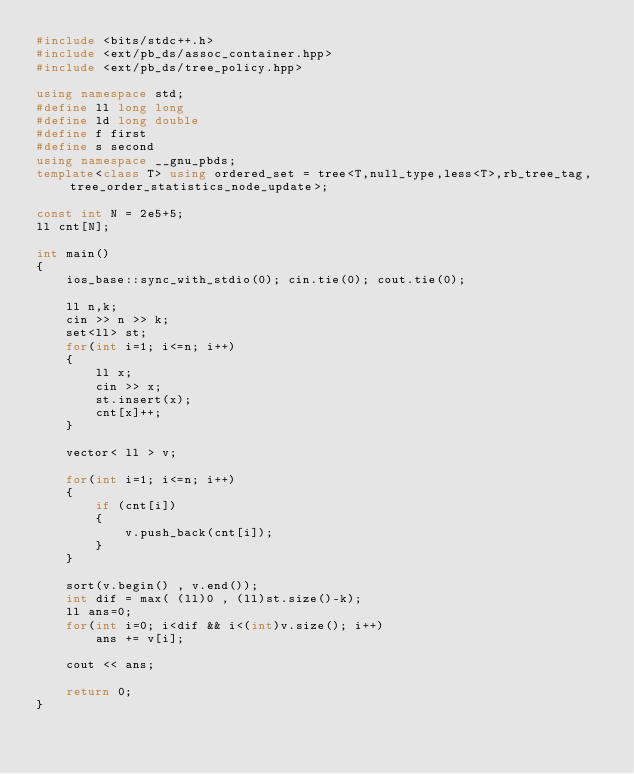Convert code to text. <code><loc_0><loc_0><loc_500><loc_500><_C++_>#include <bits/stdc++.h>
#include <ext/pb_ds/assoc_container.hpp>
#include <ext/pb_ds/tree_policy.hpp>

using namespace std;
#define ll long long
#define ld long double
#define f first
#define s second
using namespace __gnu_pbds;
template<class T> using ordered_set = tree<T,null_type,less<T>,rb_tree_tag,tree_order_statistics_node_update>;

const int N = 2e5+5;
ll cnt[N];

int main()
{
    ios_base::sync_with_stdio(0); cin.tie(0); cout.tie(0);

    ll n,k;
    cin >> n >> k;
    set<ll> st;
    for(int i=1; i<=n; i++)
    {
        ll x;
        cin >> x;
        st.insert(x);
        cnt[x]++;
    }

    vector< ll > v;

    for(int i=1; i<=n; i++)
    {
        if (cnt[i])
        {
            v.push_back(cnt[i]);
        }
    }

    sort(v.begin() , v.end());
    int dif = max( (ll)0 , (ll)st.size()-k);
    ll ans=0;
    for(int i=0; i<dif && i<(int)v.size(); i++)
        ans += v[i];

    cout << ans;

    return 0;
}</code> 